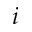<formula> <loc_0><loc_0><loc_500><loc_500>i</formula> 